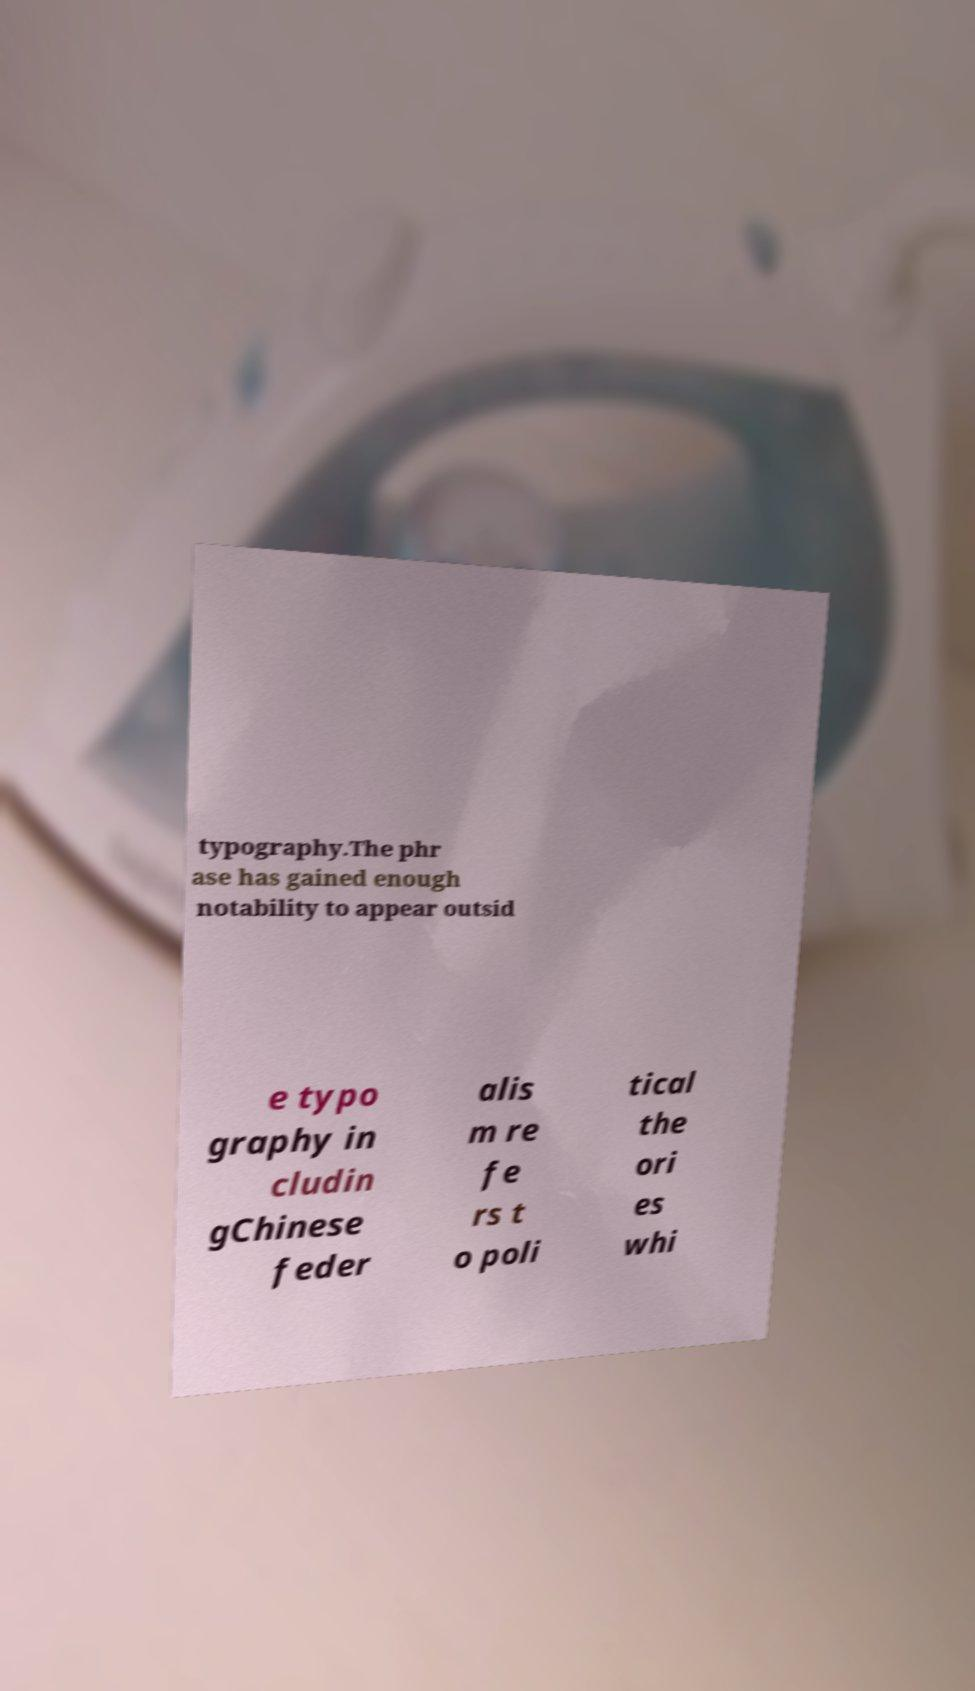I need the written content from this picture converted into text. Can you do that? typography.The phr ase has gained enough notability to appear outsid e typo graphy in cludin gChinese feder alis m re fe rs t o poli tical the ori es whi 